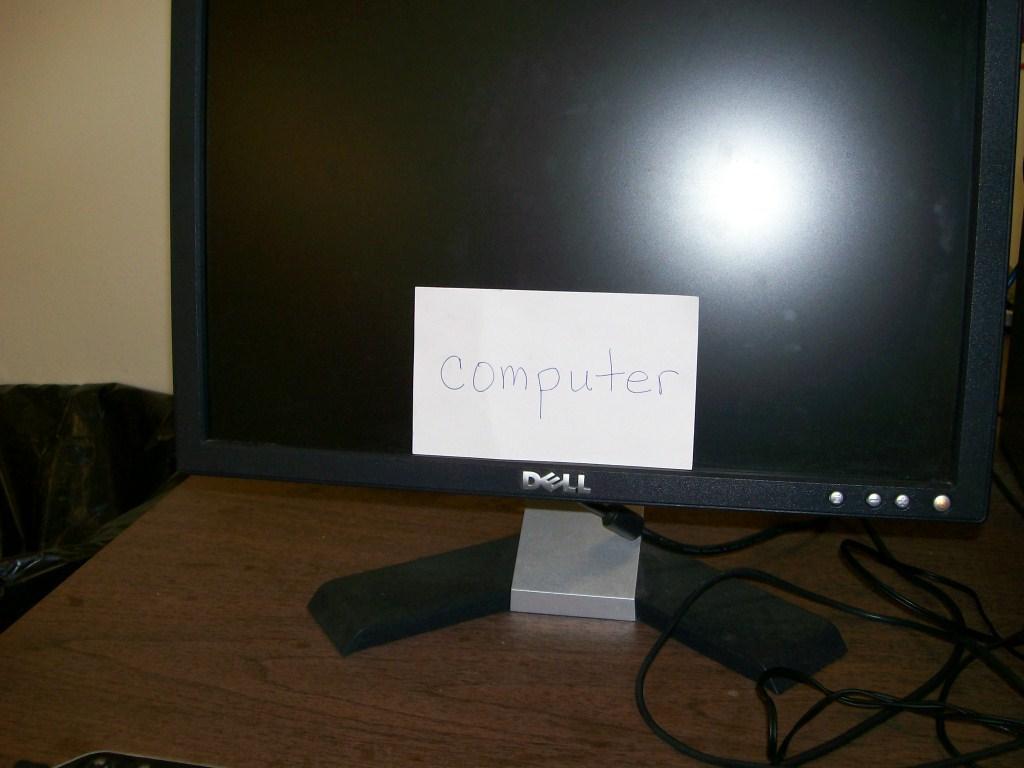What is the brand of this monitor?
Ensure brevity in your answer.  Dell. Chat is this labeled?
Provide a succinct answer. Computer. 